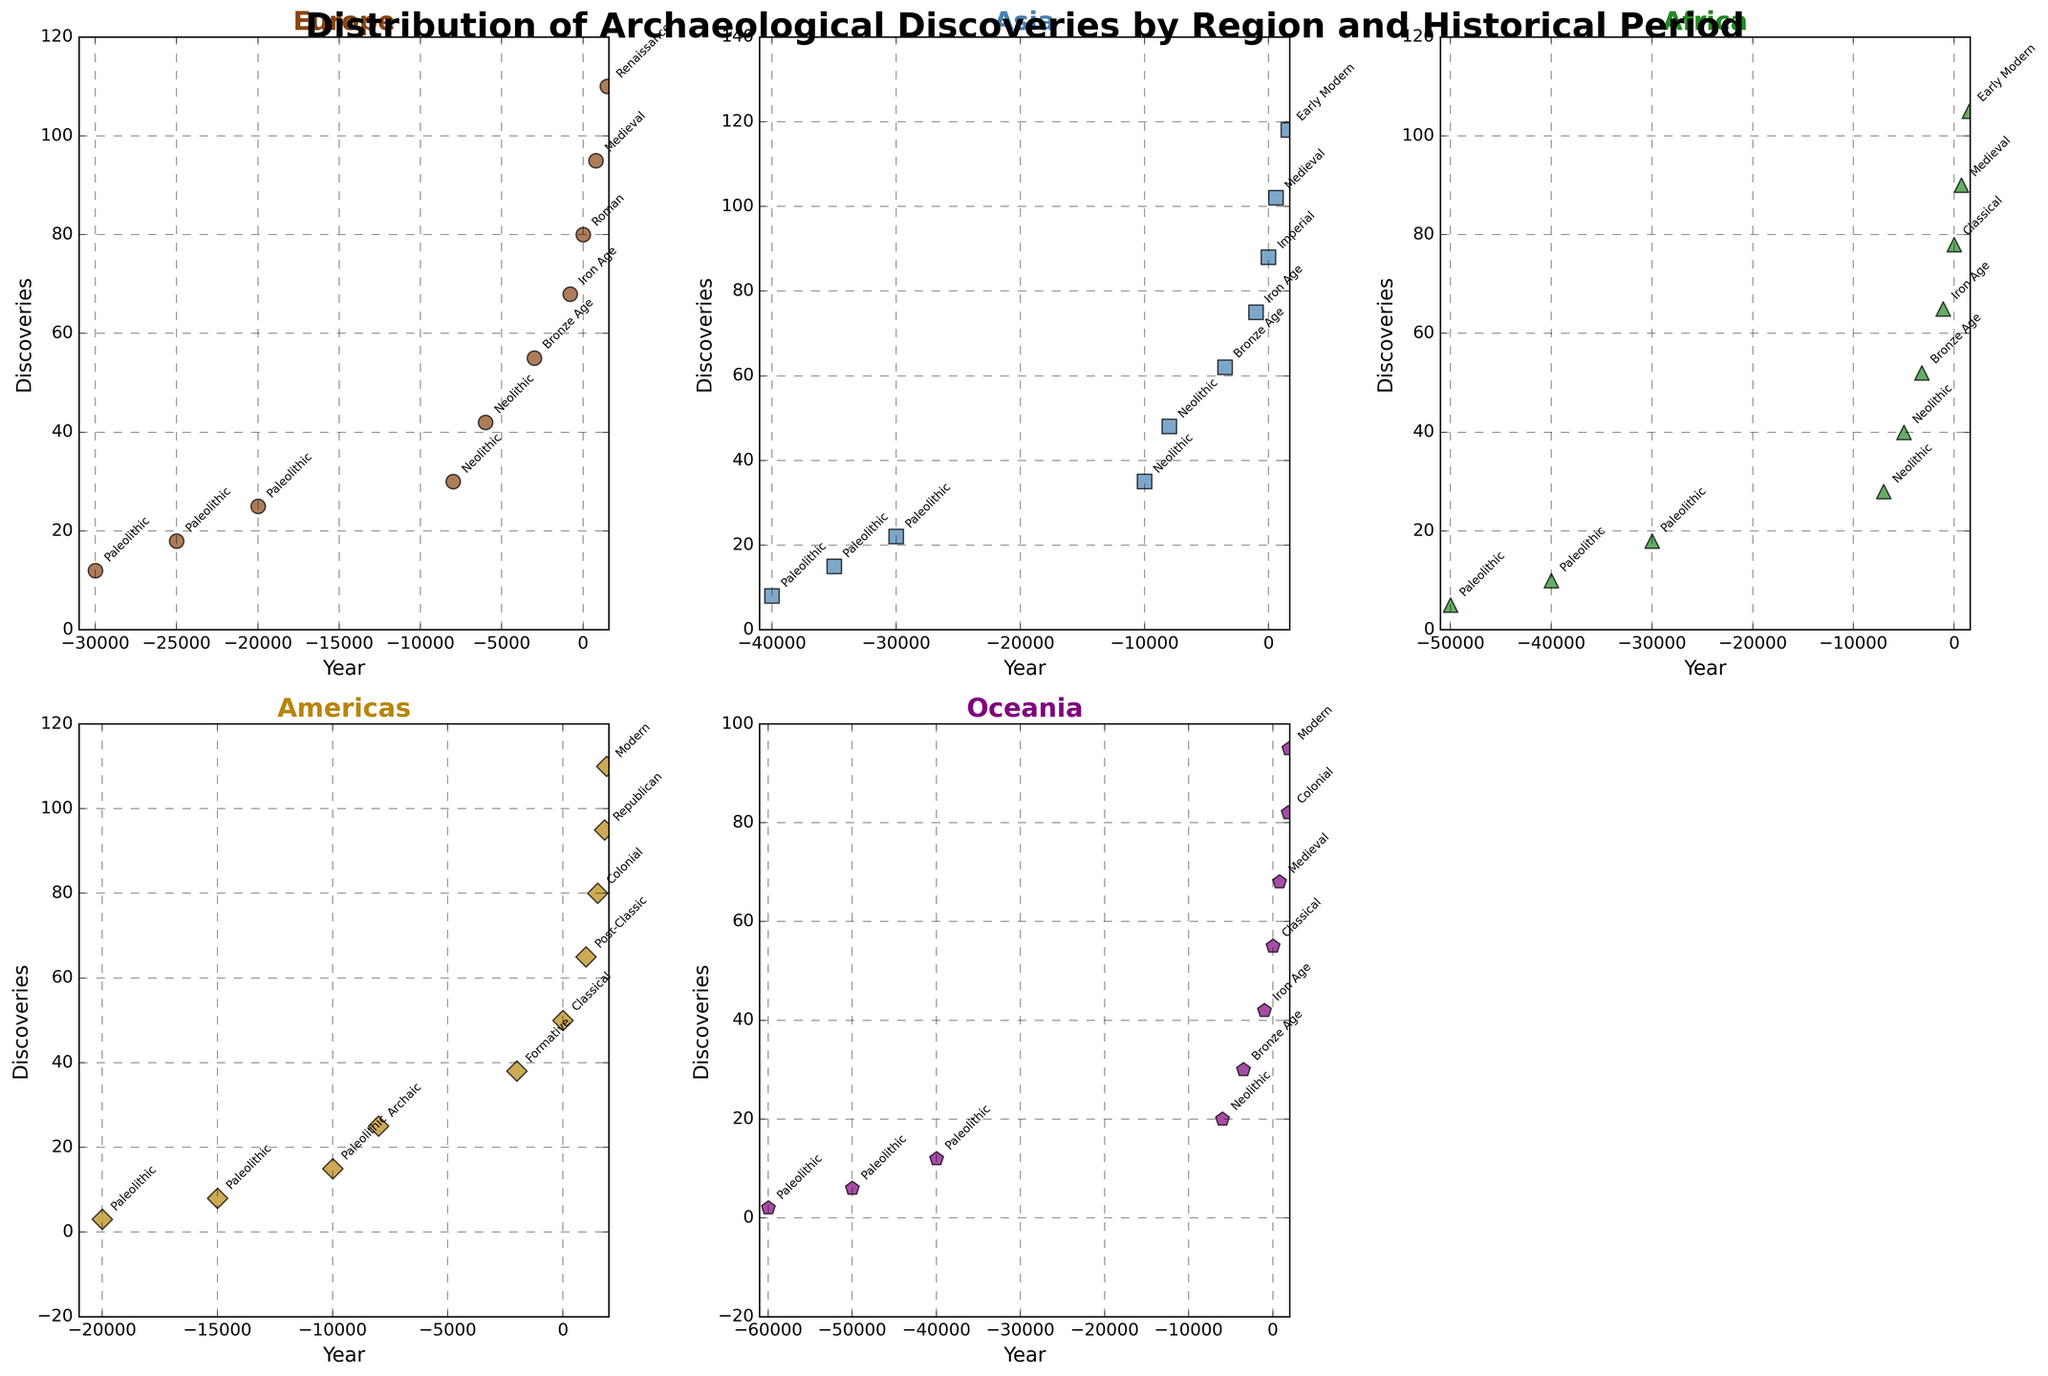Which region has the highest number of discoveries in the Modern period? Look at the scatter plots, and identify the point labeled "Modern" with the highest discovery value. The point for the Americas in 1900 has the highest number of discoveries (110).
Answer: Americas Compare the number of discoveries during the Medieval period between Asia and Africa. Which region has more discoveries? Locate the points labeled "Medieval" in the plots for Asia and Africa. Asia has 102 discoveries, while Africa has 90 discoveries.
Answer: Asia Which period in Europe has the most discoveries, and what is the discovery count? Focus on the scatter plot for Europe and identify the point with the highest y-value. The Renaissance period has the highest number of discoveries in Europe with 110 discoveries.
Answer: Renaissance, 110 Determine the average number of discoveries for the Paleolithic period across all regions. Sum the discoveries for Paleolithic in Europe (12 + 18 + 25), Asia (8 + 15 + 22), Africa (5 + 10 + 18), Americas (3 + 8 + 15), and Oceania (2 + 6 + 12). The total is 179. Divide by the number of data points (5 regions * 3 periods each = 15). 179/15 = approximately 11.93.
Answer: Approximately 11.93 Which region shows the earliest archaeological discoveries based on the labeled years? Examine the x-axis for each region's scatter plot to find the earliest year. Oceania has the earliest discovery year at -60000 (Paleolithic period).
Answer: Oceania How does the trend in discoveries from the Neolithic to the Iron Age compare between Africa and Europe? Visually inspect the scatter plots for Africa and Europe. In both regions, the number of discoveries increases from Neolithic through Bronze Age and Iron Age: Europe (30 -> 42 -> 55 -> 68), Africa (28 -> 40 -> 52 -> 65).
Answer: Increasing trend in both regions Which region has the steepest increase in discoveries from the Bronze Age to the Iron Age? Compare the changes in discoveries from the Bronze Age to the Iron Age across all regions. In Europe, the discoveries increase from 55 to 68, a difference of 13, and in Asia it increases from 62 to 75, a difference of 13. In Africa, the increase is from 52 to 65, a difference of 13. In Americas, no data for these periods. In Oceania, from 30 to 42, a difference of 12. Therefore, the steepest increases are seen in Europe, Asia, and Africa.
Answer: Europe, Asia, Africa What is the range of years represented in the discoveries for the Americas? Identify the minimum and maximum x-axis values for the Americas. The range is from -20000 to 1900.
Answer: -20000 to 1900 What color and marker type represent Asia in the scatter plots? In the scatter plot, observe the color and marker type associated with the "Asia" title. It is indicated with a blue color and a square marker.
Answer: Blue, square 